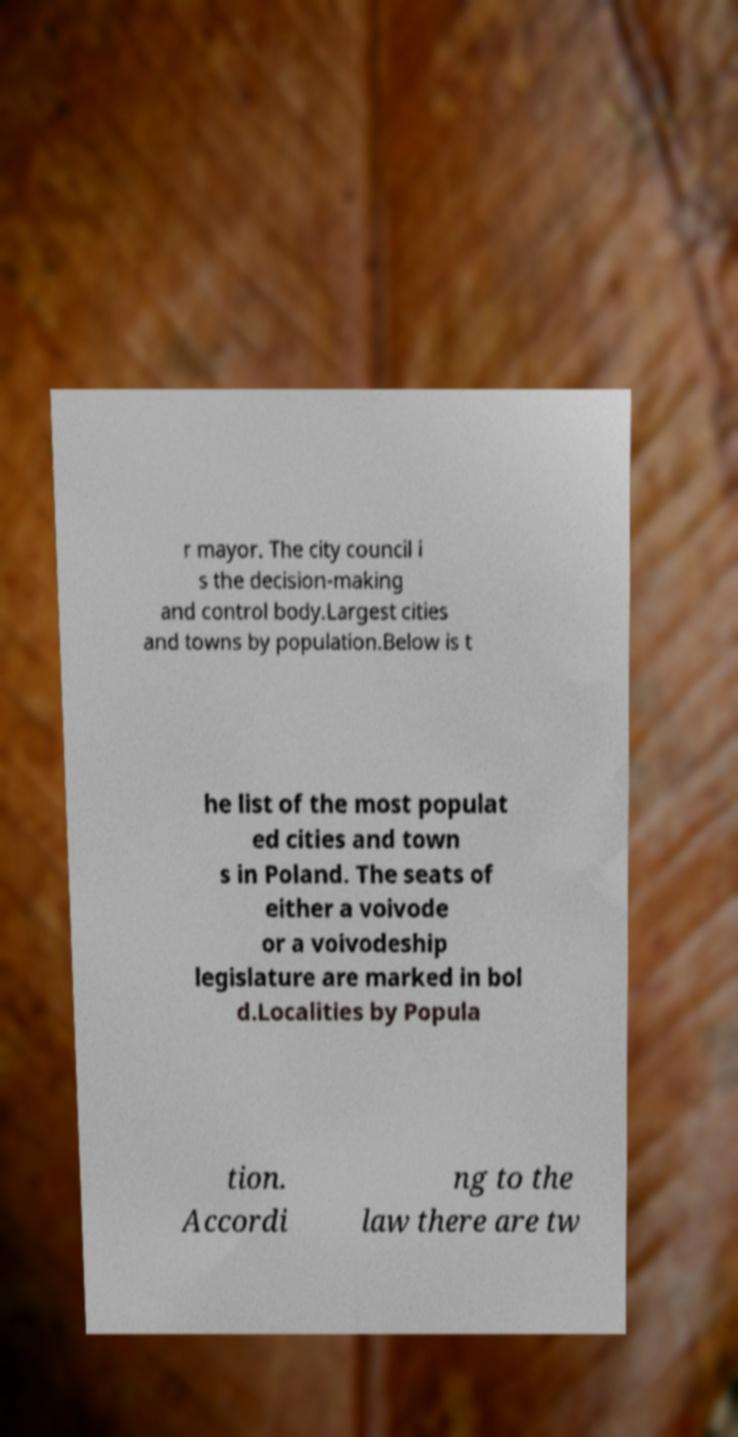Could you extract and type out the text from this image? r mayor. The city council i s the decision-making and control body.Largest cities and towns by population.Below is t he list of the most populat ed cities and town s in Poland. The seats of either a voivode or a voivodeship legislature are marked in bol d.Localities by Popula tion. Accordi ng to the law there are tw 